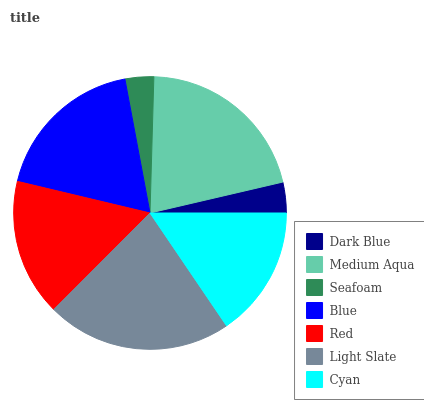Is Seafoam the minimum?
Answer yes or no. Yes. Is Light Slate the maximum?
Answer yes or no. Yes. Is Medium Aqua the minimum?
Answer yes or no. No. Is Medium Aqua the maximum?
Answer yes or no. No. Is Medium Aqua greater than Dark Blue?
Answer yes or no. Yes. Is Dark Blue less than Medium Aqua?
Answer yes or no. Yes. Is Dark Blue greater than Medium Aqua?
Answer yes or no. No. Is Medium Aqua less than Dark Blue?
Answer yes or no. No. Is Red the high median?
Answer yes or no. Yes. Is Red the low median?
Answer yes or no. Yes. Is Medium Aqua the high median?
Answer yes or no. No. Is Seafoam the low median?
Answer yes or no. No. 